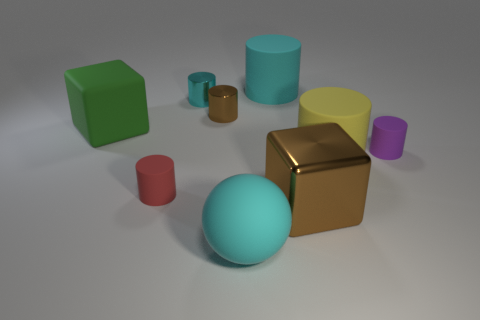Can you describe the texture of the objects?  Certainly! The objects exhibit a variety of textures. The green and yellow cubes show a slight roughness, which suggests a matte finish. The metallic cube has a reflective surface with a high sheen, indicative of a polished material. The other objects, including the cylinders and the sphere, appear smooth with varying degrees of matte and reflective finishes. Which object seems out of place in this collection? While 'out of place' is subjective, the gold-colored cube stands out due to its reflective, mirror-like surface that differs significantly from the mattes and less reflective surfaces of the other objects. Its luxurious appearance contrasts with the simplicity of the surrounding items. 